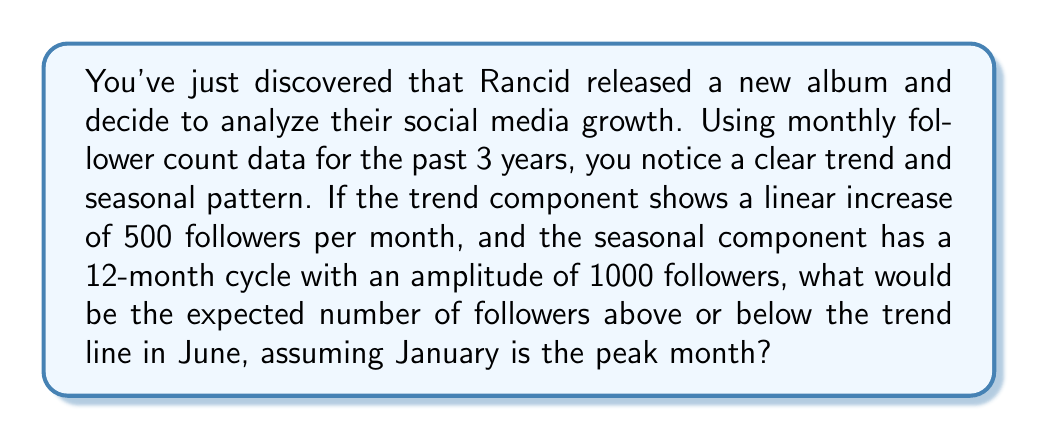Could you help me with this problem? To solve this problem, we need to decompose the time series into its components and focus on the seasonal pattern. Let's break it down step-by-step:

1) The time series can be decomposed into three main components:
   $Y_t = T_t + S_t + R_t$
   where $Y_t$ is the observed value, $T_t$ is the trend, $S_t$ is the seasonal component, and $R_t$ is the residual.

2) We're told that the trend is linear, increasing by 500 followers per month. This isn't relevant to our question about the seasonal component.

3) The seasonal component has a 12-month cycle with an amplitude of 1000 followers. This means that the difference between the peak and trough is 2000 followers.

4) We're told that January is the peak month. This means the seasonal pattern will follow a cosine function with a period of 12 months:

   $S_t = A \cos(\frac{2\pi}{12}(t-1))$

   where $A$ is the amplitude (1000 in this case) and $t$ is the month number (1 for January, 2 for February, etc.)

5) To find the value for June, we need to calculate $t=6$:

   $S_6 = 1000 \cos(\frac{2\pi}{12}(6-1))$
        $= 1000 \cos(\frac{5\pi}{6})$
        $= 1000 \cdot (-\frac{\sqrt{3}}{2})$
        $= -866.03$

6) This negative value indicates that in June, the follower count is expected to be 866.03 below the trend line.
Answer: The expected number of followers below the trend line in June is approximately 866.03. 